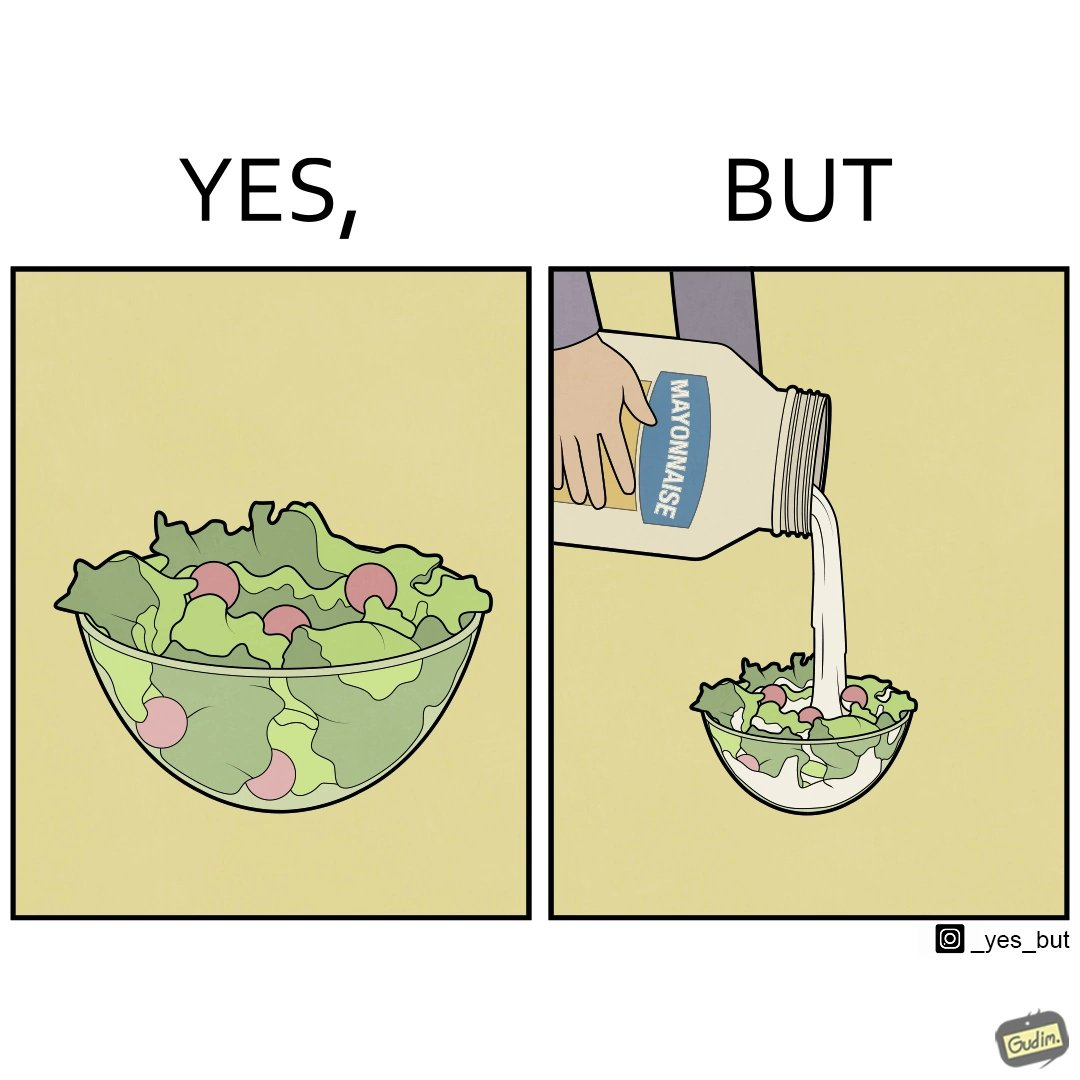Is this image satirical or non-satirical? Yes, this image is satirical. 